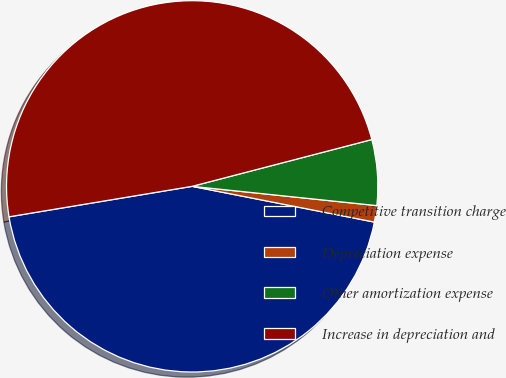<chart> <loc_0><loc_0><loc_500><loc_500><pie_chart><fcel>Competitive transition charge<fcel>Depreciation expense<fcel>Other amortization expense<fcel>Increase in depreciation and<nl><fcel>44.29%<fcel>1.43%<fcel>5.71%<fcel>48.57%<nl></chart> 